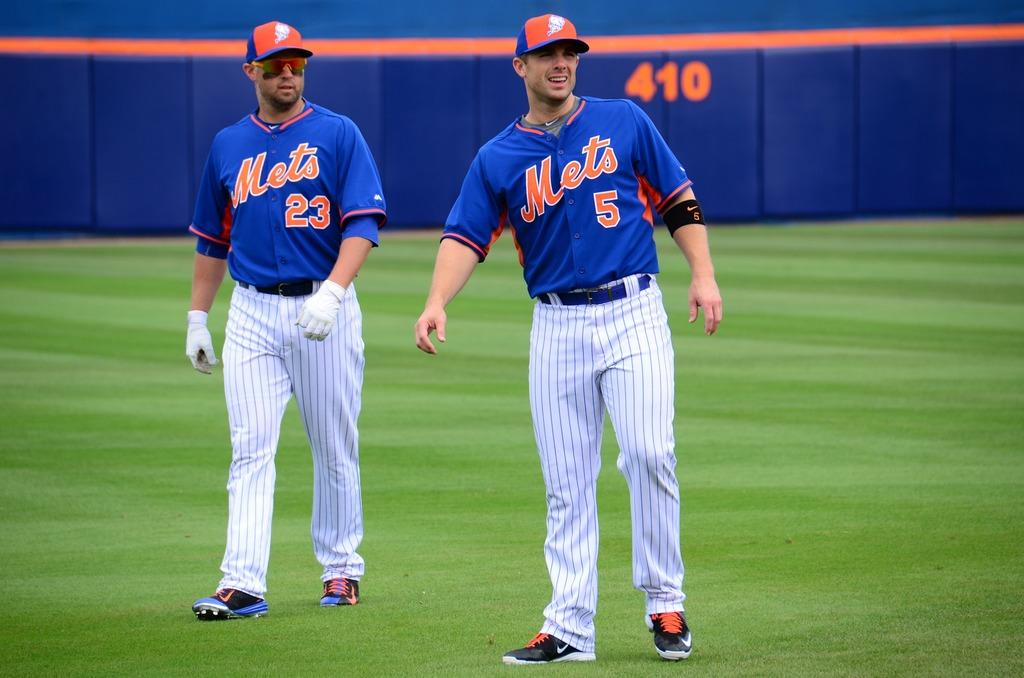<image>
Create a compact narrative representing the image presented. Player number 23 and player number 5 from the Mets team stand on the baseball field. 